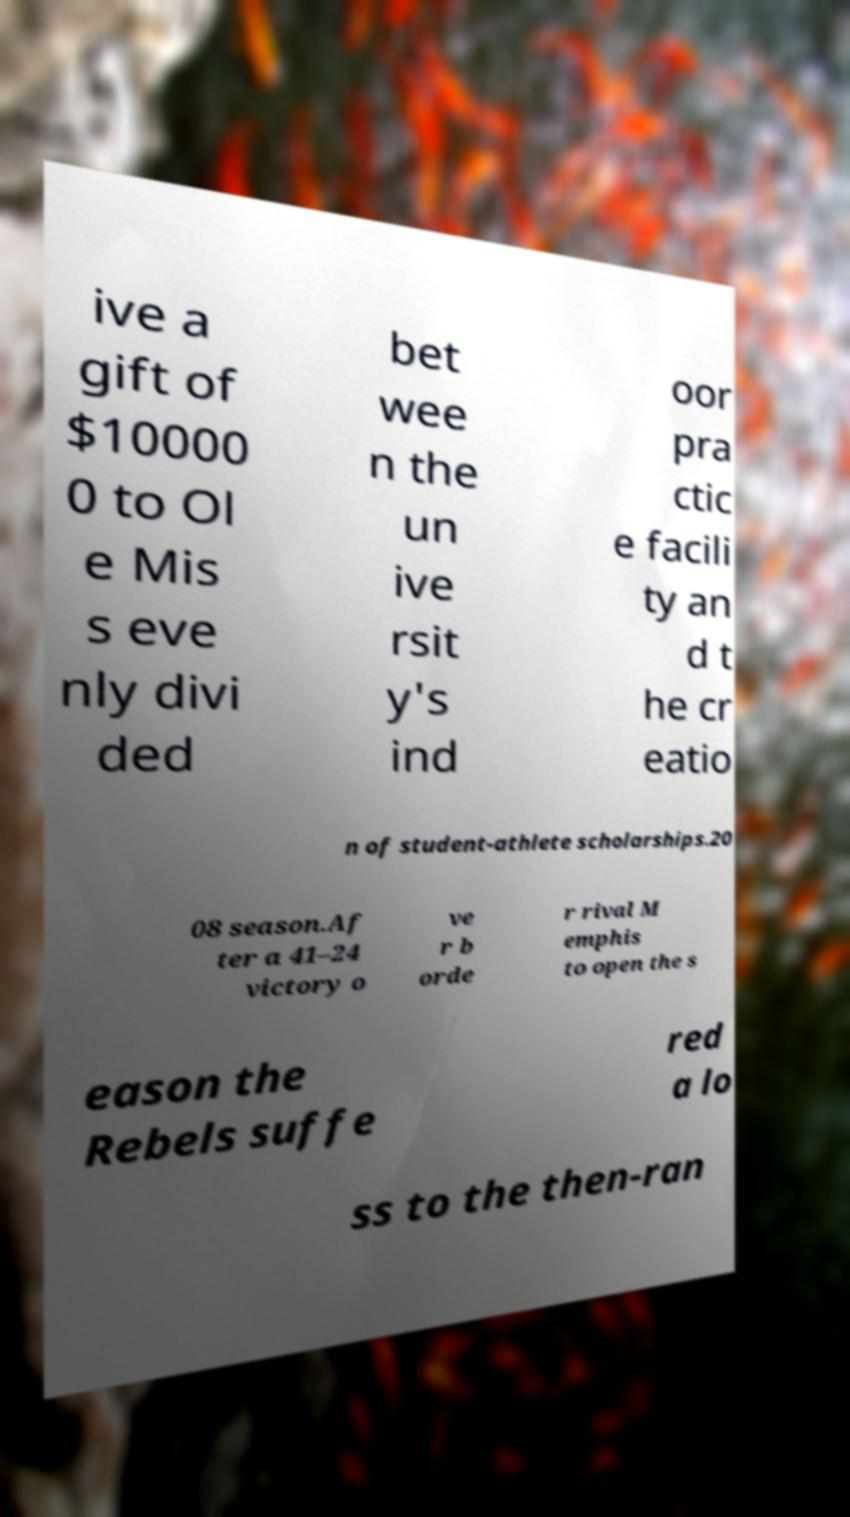For documentation purposes, I need the text within this image transcribed. Could you provide that? ive a gift of $10000 0 to Ol e Mis s eve nly divi ded bet wee n the un ive rsit y's ind oor pra ctic e facili ty an d t he cr eatio n of student-athlete scholarships.20 08 season.Af ter a 41–24 victory o ve r b orde r rival M emphis to open the s eason the Rebels suffe red a lo ss to the then-ran 